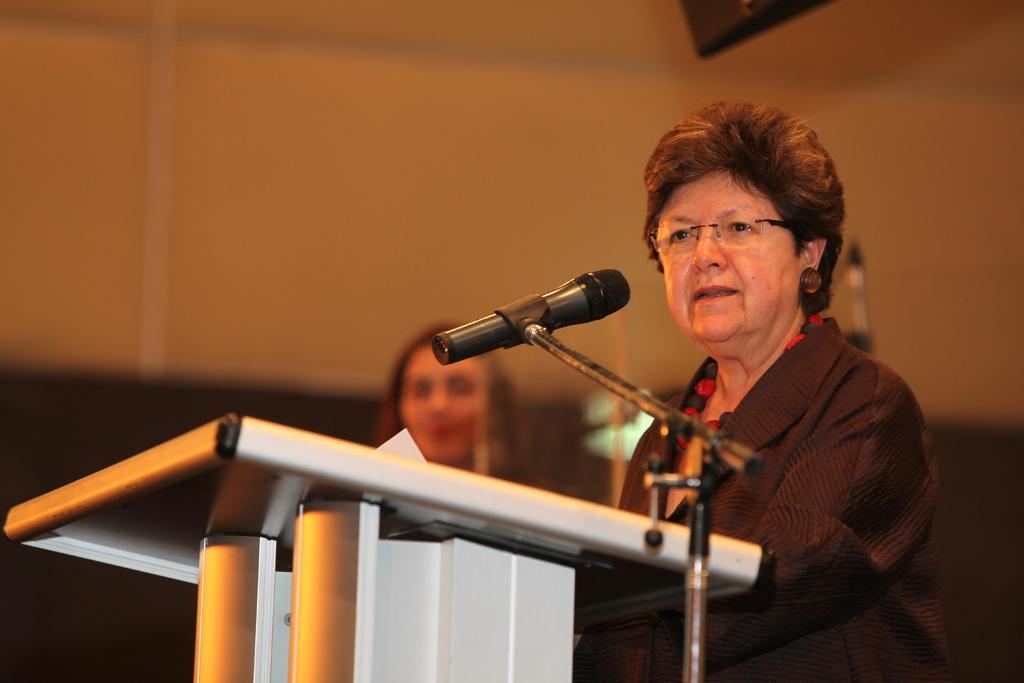Who is the person on the right side of the image? There is a woman on the right side of the image. What is the woman standing near in the image? There is a podium in the image. What is the woman holding in the image? There is a mic on a stand in the image. Can you describe the background of the image? There is a person, a wall, and some objects in the background of the image. What type of eggnog is being served at the event in the image? There is no mention of eggnog or any event in the image; it simply shows a woman standing near a podium with a mic on a stand. What is the reason for the woman's presence in the image? The image does not provide any information about the woman's purpose or reason for being there. 